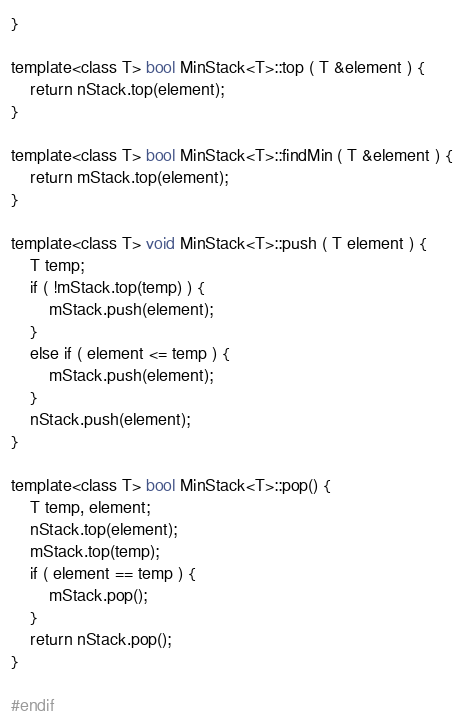Convert code to text. <code><loc_0><loc_0><loc_500><loc_500><_C_>}

template<class T> bool MinStack<T>::top ( T &element ) {
	return nStack.top(element);
}

template<class T> bool MinStack<T>::findMin ( T &element ) {
	return mStack.top(element);
}

template<class T> void MinStack<T>::push ( T element ) {
	T temp;
	if ( !mStack.top(temp) ) {
		mStack.push(element);
	}
	else if ( element <= temp ) {
		mStack.push(element);
	}
	nStack.push(element);
}

template<class T> bool MinStack<T>::pop() {
	T temp, element;
	nStack.top(element);
	mStack.top(temp);
	if ( element == temp ) {
		mStack.pop();
	}
	return nStack.pop();
}

#endif</code> 